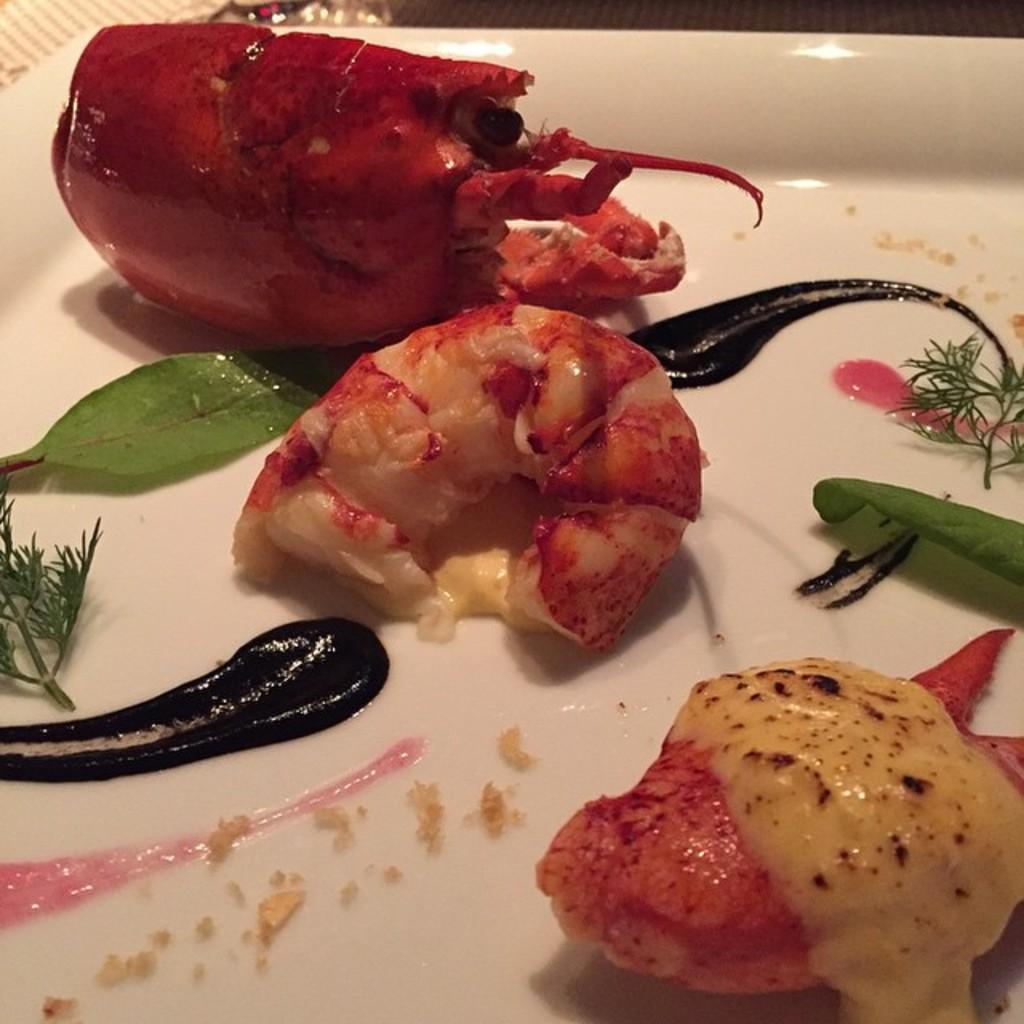Describe this image in one or two sentences. In this image I can see food which is in red and cream color in the plate and the plate is in white color. 